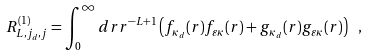Convert formula to latex. <formula><loc_0><loc_0><loc_500><loc_500>R ^ { ( 1 ) } _ { L , j _ { d } , j } = \int _ { 0 } ^ { \infty } d r r ^ { - L + 1 } \left ( f _ { \kappa _ { d } } ( r ) f _ { \varepsilon \kappa } ( r ) + g _ { \kappa _ { d } } ( r ) g _ { \varepsilon \kappa } ( r ) \right ) \ ,</formula> 